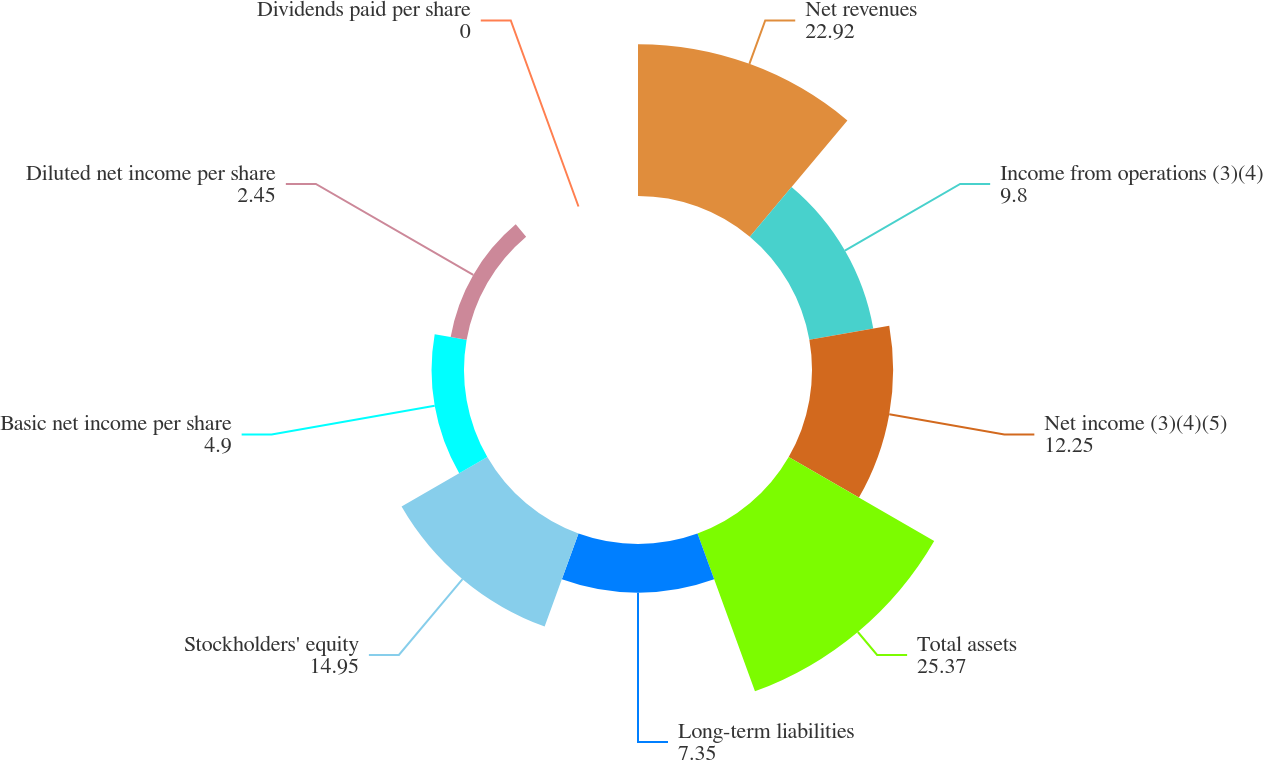<chart> <loc_0><loc_0><loc_500><loc_500><pie_chart><fcel>Net revenues<fcel>Income from operations (3)(4)<fcel>Net income (3)(4)(5)<fcel>Total assets<fcel>Long-term liabilities<fcel>Stockholders' equity<fcel>Basic net income per share<fcel>Diluted net income per share<fcel>Dividends paid per share<nl><fcel>22.92%<fcel>9.8%<fcel>12.25%<fcel>25.37%<fcel>7.35%<fcel>14.95%<fcel>4.9%<fcel>2.45%<fcel>0.0%<nl></chart> 